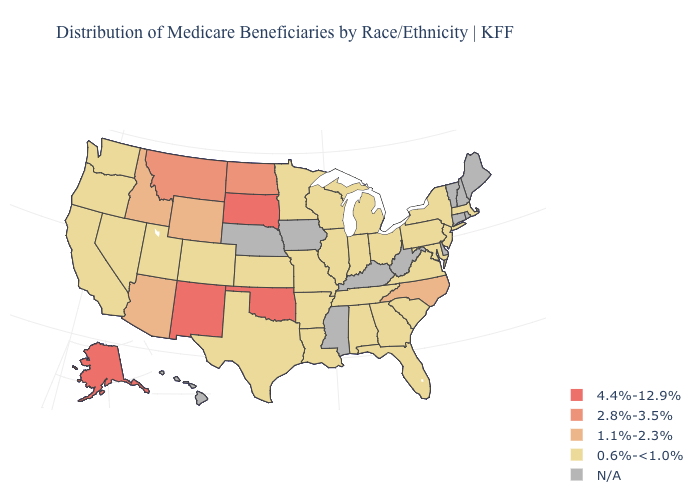Which states hav the highest value in the MidWest?
Be succinct. South Dakota. What is the value of Maine?
Write a very short answer. N/A. What is the lowest value in the Northeast?
Short answer required. 0.6%-<1.0%. Which states have the lowest value in the West?
Quick response, please. California, Colorado, Nevada, Oregon, Utah, Washington. Among the states that border Idaho , does Montana have the highest value?
Write a very short answer. Yes. What is the value of Oregon?
Give a very brief answer. 0.6%-<1.0%. Which states hav the highest value in the Northeast?
Concise answer only. Massachusetts, New Jersey, New York, Pennsylvania. What is the value of Michigan?
Concise answer only. 0.6%-<1.0%. What is the value of Louisiana?
Write a very short answer. 0.6%-<1.0%. Does the first symbol in the legend represent the smallest category?
Answer briefly. No. Name the states that have a value in the range 0.6%-<1.0%?
Short answer required. Alabama, Arkansas, California, Colorado, Florida, Georgia, Illinois, Indiana, Kansas, Louisiana, Maryland, Massachusetts, Michigan, Minnesota, Missouri, Nevada, New Jersey, New York, Ohio, Oregon, Pennsylvania, South Carolina, Tennessee, Texas, Utah, Virginia, Washington, Wisconsin. Does Missouri have the lowest value in the USA?
Short answer required. Yes. What is the value of Virginia?
Answer briefly. 0.6%-<1.0%. Among the states that border Nebraska , does Kansas have the lowest value?
Keep it brief. Yes. 